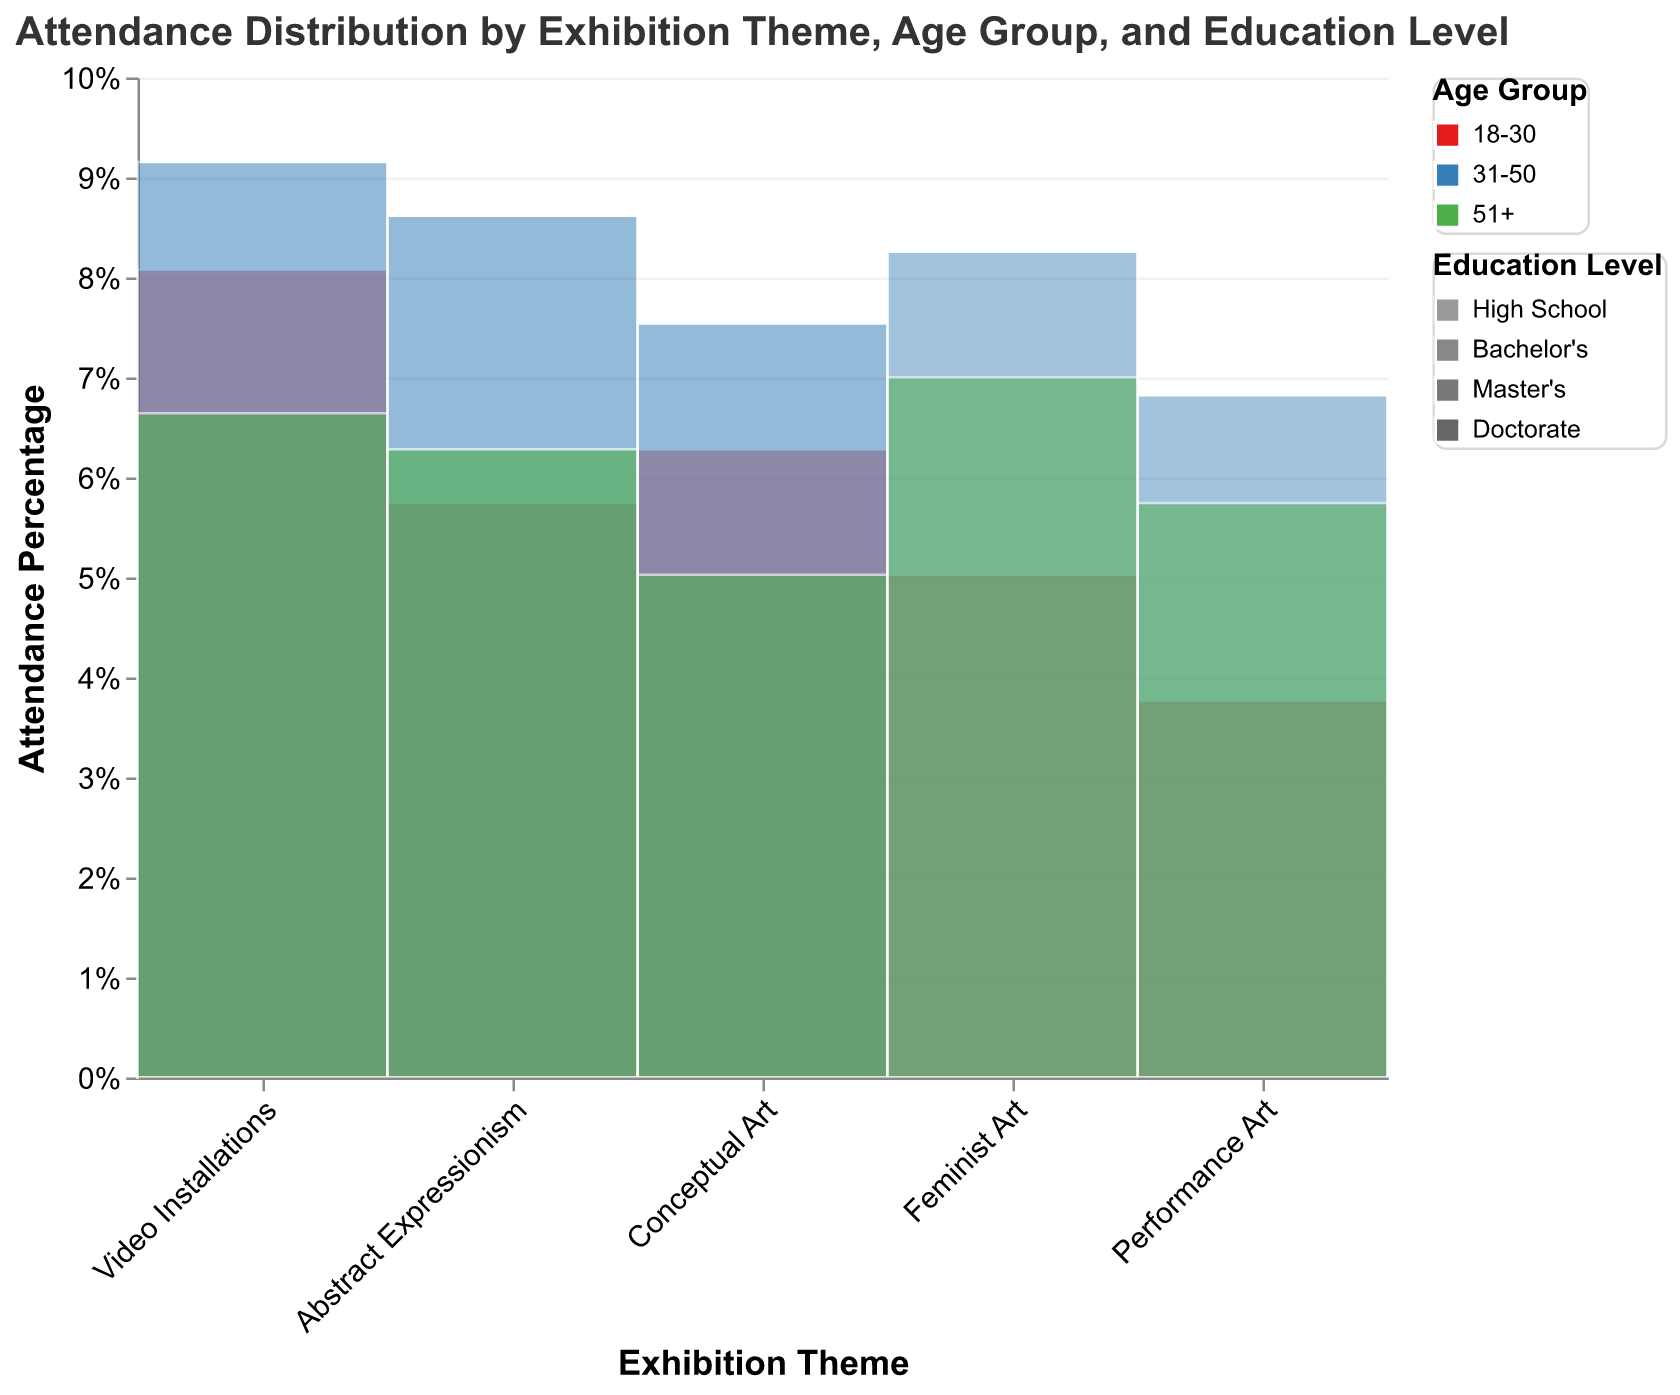What is the total attendance percentage for Video Installations? To find the total attendance percentage for Video Installations, sum the percentages for all age groups and education levels within this theme from the figure. The percentages are likely normalized to sum to 100%.
Answer: 100% Which exhibition theme has the highest attendance percentage for the age group 18-30? Look at the color representing the age group 18-30 in the figure and compare the height of the segments across different exhibition themes. The exhibition theme with the highest segment for this color represents the highest attendance percentage.
Answer: Video Installations What is the attendance percentage difference between Performance Art and Feminist Art for visitors aged 31-50? Identify the color segments for the age group 31-50 for both Performance Art and Feminist Art. Subtract the percentage of Feminist Art from Performance Art.
Answer: Performance Art's 31-50 (yellow) and Feminist Art's 31-50 (orange) Which education level has the least representation in Conceptual Art? Check the opacity levels in the Conceptual Art category. The lightest segments indicate the education level with the least representation.
Answer: Doctorate Is Abstract Expressionism more popular among the 31-50 age group or the 51+ age group? Compare the height of the segments corresponding to the 31-50 age group and the 51+ age group within the Abstract Expressionism exhibit theme. The taller segment represents the more popular age group.
Answer: 31-50 age group What is the total attendance for visitors with a Master's degree? Sum the attendance values for visitors with a Master's degree across all exhibition themes. The attendance values are provided in the data table used to generate the figure.
Answer: 20,200 For which exhibition theme is the attendance for visitors aged 18-30 and having a Bachelor's degree the highest? Identify the segments corresponding to 18-30 and Bachelor's degree in all exhibition themes. The theme with the highest segment for this group will be the answer.
Answer: Video Installations Which age group has the highest overall attendance across all exhibition themes? Sum the attendance values of each age group across all exhibition themes and compare the totals.
Answer: 31-50 How does the attendance for Video Installations compare to Performance Art in terms of percentages for visitors with a Doctorate? Look at the height of the segments corresponding to visitors with a Doctorate in both Video Installations and Performance Art. The taller segment indicates higher attendance percentage.
Answer: Video Installations Is there a theme where visitors with only a High School education have the majority percentage of attendance? Check the figures for each theme to see if the High School education level segment is the predominant segment in any of the themes.
Answer: No 